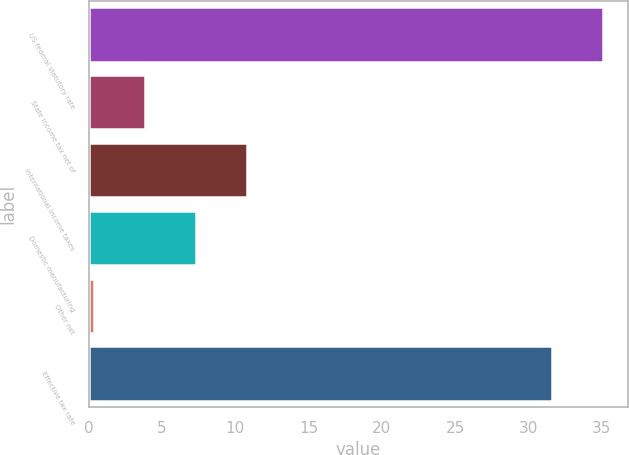Convert chart to OTSL. <chart><loc_0><loc_0><loc_500><loc_500><bar_chart><fcel>US federal statutory rate<fcel>State income tax net of<fcel>International income taxes<fcel>Domestic manufacturing<fcel>Other net<fcel>Effective tax rate<nl><fcel>35.06<fcel>3.86<fcel>10.78<fcel>7.32<fcel>0.4<fcel>31.6<nl></chart> 